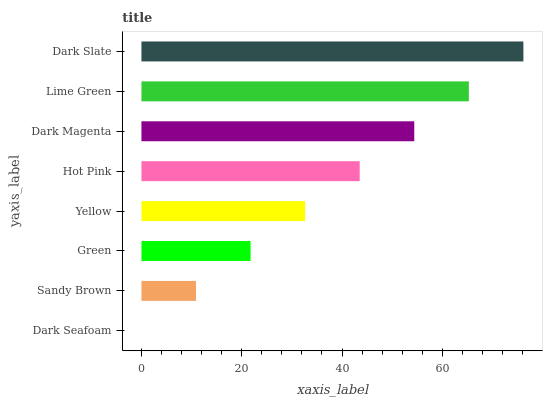Is Dark Seafoam the minimum?
Answer yes or no. Yes. Is Dark Slate the maximum?
Answer yes or no. Yes. Is Sandy Brown the minimum?
Answer yes or no. No. Is Sandy Brown the maximum?
Answer yes or no. No. Is Sandy Brown greater than Dark Seafoam?
Answer yes or no. Yes. Is Dark Seafoam less than Sandy Brown?
Answer yes or no. Yes. Is Dark Seafoam greater than Sandy Brown?
Answer yes or no. No. Is Sandy Brown less than Dark Seafoam?
Answer yes or no. No. Is Hot Pink the high median?
Answer yes or no. Yes. Is Yellow the low median?
Answer yes or no. Yes. Is Yellow the high median?
Answer yes or no. No. Is Lime Green the low median?
Answer yes or no. No. 